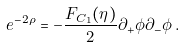<formula> <loc_0><loc_0><loc_500><loc_500>e ^ { - 2 \rho } = - \frac { F _ { C _ { 1 } } ( \eta ) } { 2 } \partial _ { + } \phi \partial _ { - } \phi \, .</formula> 